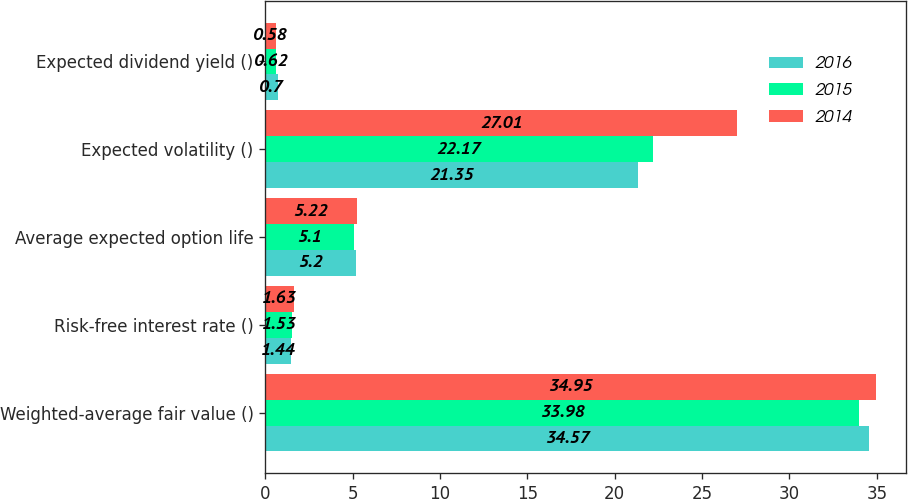<chart> <loc_0><loc_0><loc_500><loc_500><stacked_bar_chart><ecel><fcel>Weighted-average fair value ()<fcel>Risk-free interest rate ()<fcel>Average expected option life<fcel>Expected volatility ()<fcel>Expected dividend yield ()<nl><fcel>2016<fcel>34.57<fcel>1.44<fcel>5.2<fcel>21.35<fcel>0.7<nl><fcel>2015<fcel>33.98<fcel>1.53<fcel>5.1<fcel>22.17<fcel>0.62<nl><fcel>2014<fcel>34.95<fcel>1.63<fcel>5.22<fcel>27.01<fcel>0.58<nl></chart> 